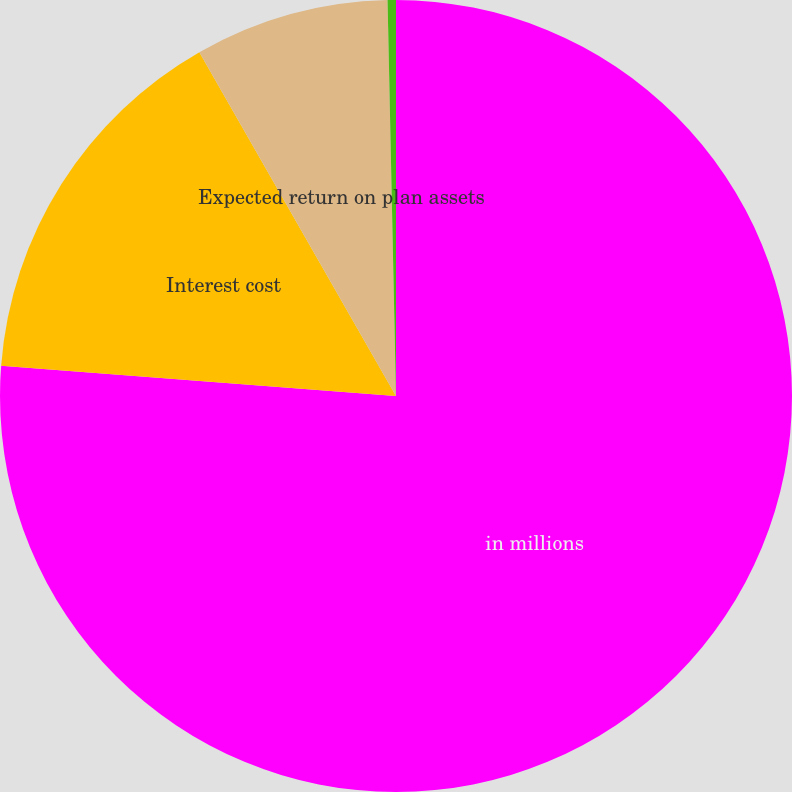Convert chart to OTSL. <chart><loc_0><loc_0><loc_500><loc_500><pie_chart><fcel>in millions<fcel>Interest cost<fcel>Expected return on plan assets<fcel>Net periodic benefit cost<nl><fcel>76.22%<fcel>15.51%<fcel>7.93%<fcel>0.34%<nl></chart> 